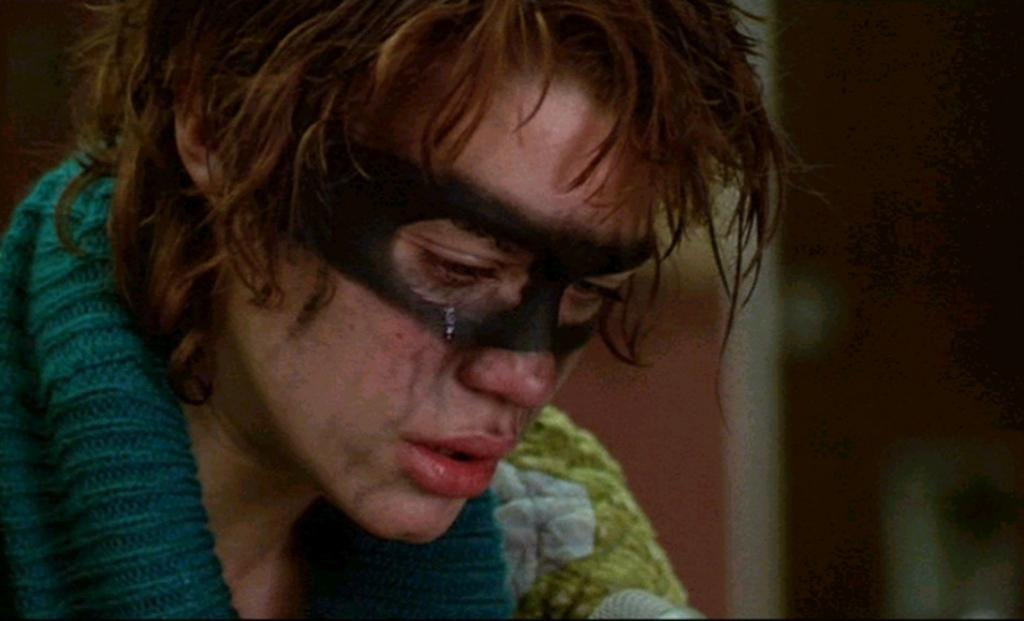What can be seen in the image? There is a person in the image. Can you describe the person's attire? The person is wearing a green and white color dress. How would you describe the background of the image? The background is blurred. What type of stamp can be seen on the person's dress in the image? There is no stamp visible on the person's dress in the image. Can you describe the cemetery in the background of the image? There is no cemetery present in the image; the background is blurred. 